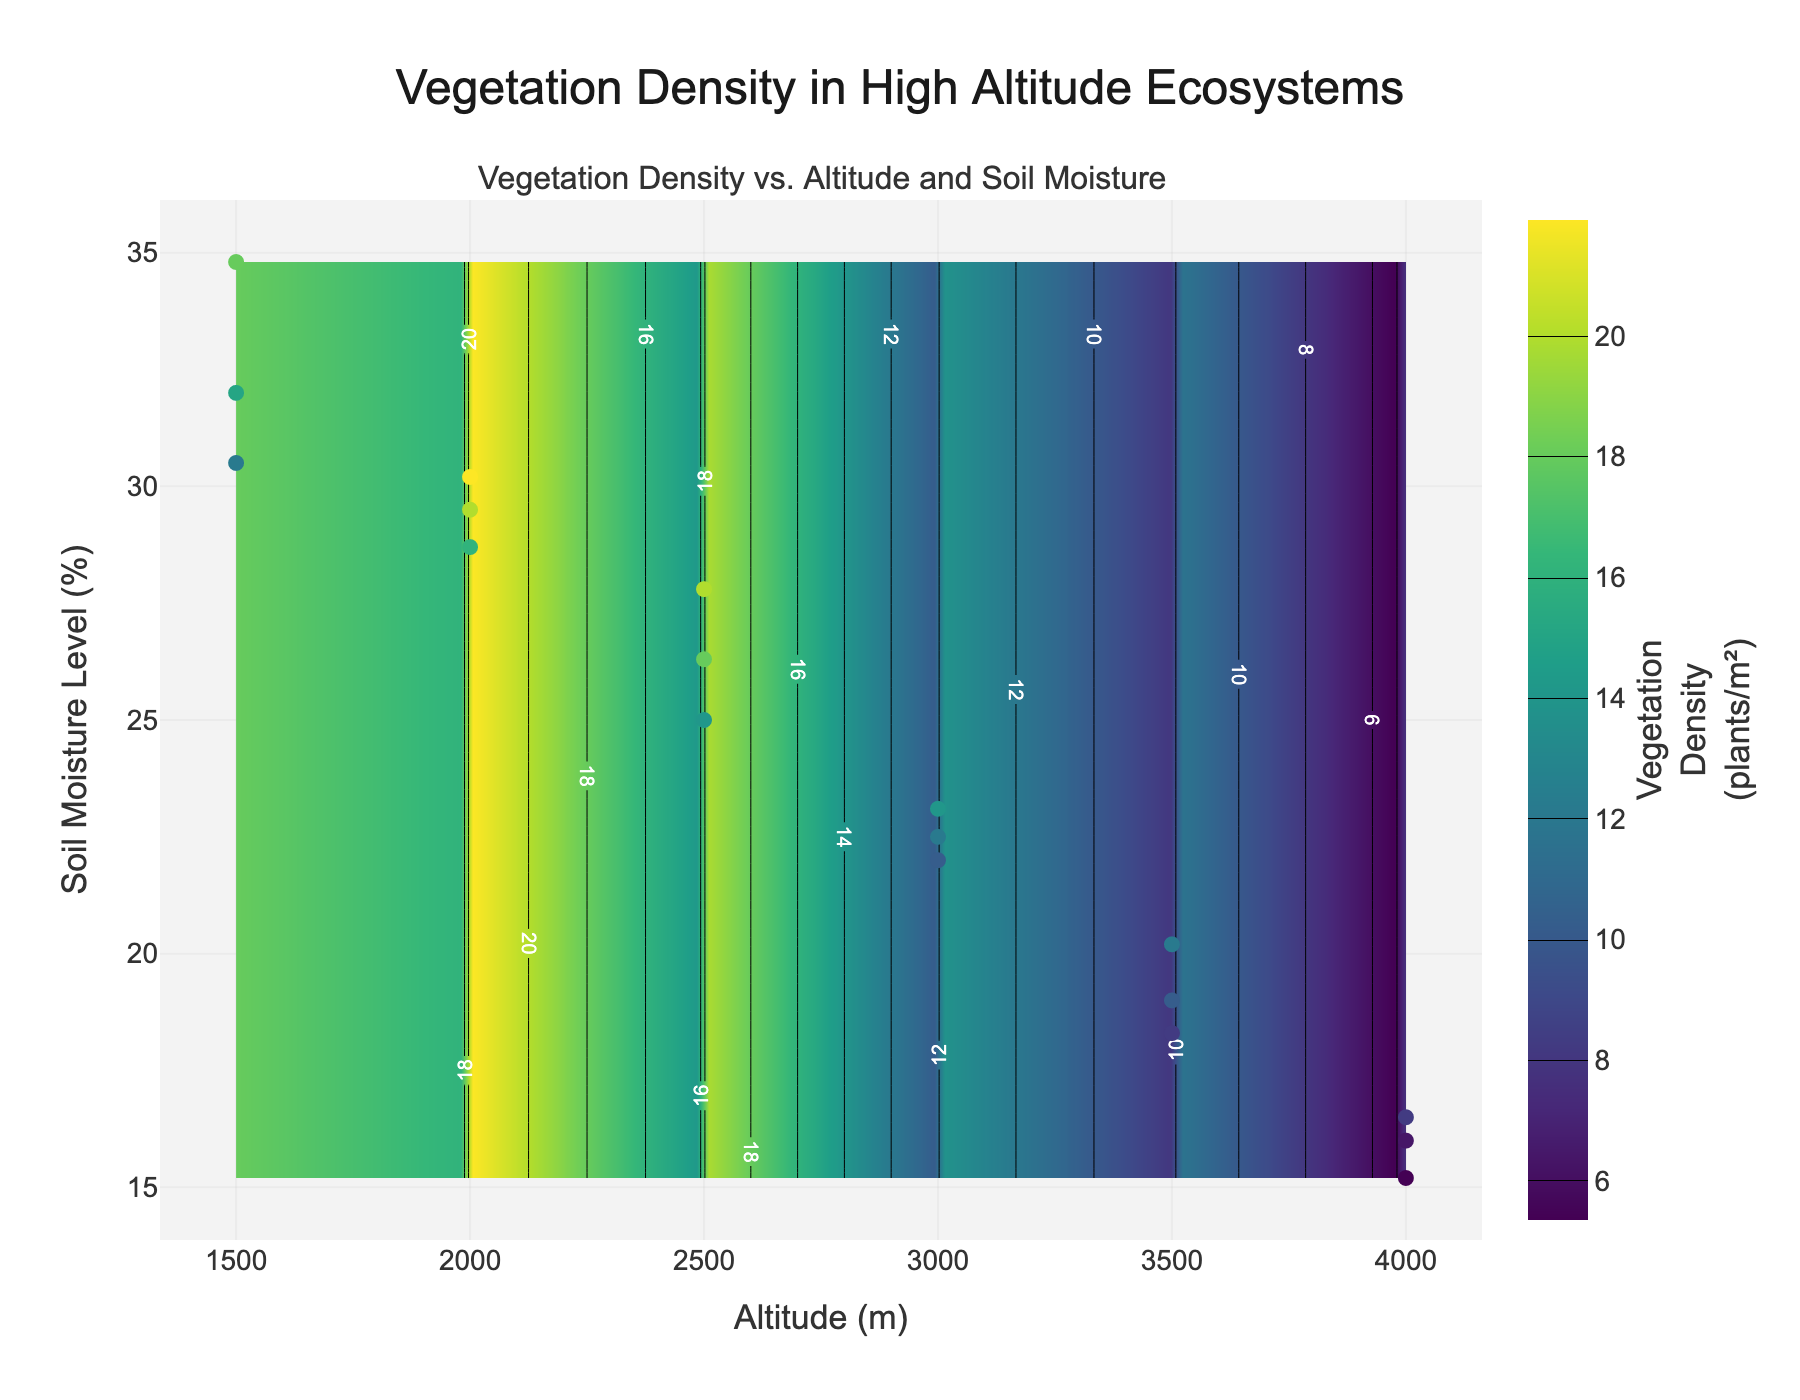What is the title of the plot? The title of the plot is located at the top of the figure. It is often meant to provide a brief description of what the figure represents. In this case, it mentions the context of the study, which is focused on vegetation density in high altitude ecosystems.
Answer: Vegetation Density in High Altitude Ecosystems What do the x and y axes represent? The x and y axes represent different parameters. The x-axis represents "Altitude (m)" while the y-axis represents "Soil Moisture Level (%)". These axes help in understanding how these two variables relate to each other and to vegetation density.
Answer: Altitude (m) and Soil Moisture Level (%) What color scale is used in the contour plot? The contour plot uses a color scale to represent different values of vegetation density. The color scale used is 'Viridis', which usually ranges from blue (low values) to yellow (high values).
Answer: Viridis How many data points are plotted as markers on the graph? To find the number of data points plotted as markers, we look at the distinct points on the plot. According to the given data, each altitude has multiple corresponding soil moisture levels and vegetation density values. Since there are 17 data points in the provided dataset, there are 17 markers on the graph.
Answer: 17 Which altitude has the highest soil moisture level? To find the highest soil moisture level, we look at the y-axis values and identify the maximum point. The highest soil moisture level in the dataset is 34.8%, which occurs at an altitude of 1500 meters.
Answer: 1500 meters What is the trend of vegetation density with increasing altitude? Observing the contour and scatter plots can reveal the trend. The general trend shows that vegetation density decreases with increasing altitude. Higher altitudes have lower soil moisture levels and correspondingly lower vegetation densities.
Answer: Decreases with increasing altitude At an altitude of 2500 meters, what is the range of soil moisture levels recorded? By examining the scatter points on the graph for an altitude of 2500 meters, we note that the soil moisture levels vary between 25.0% and 27.8%.
Answer: 25.0% to 27.8% Is there a correlation between vegetation density and soil moisture level? By examining the contour plots and scatter points, we can see that areas with higher soil moisture levels generally have higher vegetation densities. This indicates a positive correlation between soil moisture level and vegetation density.
Answer: Positive correlation How does vegetation density change from 3000 meters to 3500 meters? To evaluate this change, we compare the vegetation density values at these two altitudes. At 3000 meters, the vegetation density ranges from 10 to 14 plants/m², whereas at 3500 meters, it ranges from 8 to 12 plants/m². Therefore, vegetation density decreases from 3000 meters to 3500 meters.
Answer: Decreases Which altitude has the lowest recorded soil moisture level, and what is that level? By checking the lowest point on the y-axis values for each altitude, we find that the lowest soil moisture level is 15.2%, recorded at an altitude of 4000 meters.
Answer: 4000 meters and 15.2% 